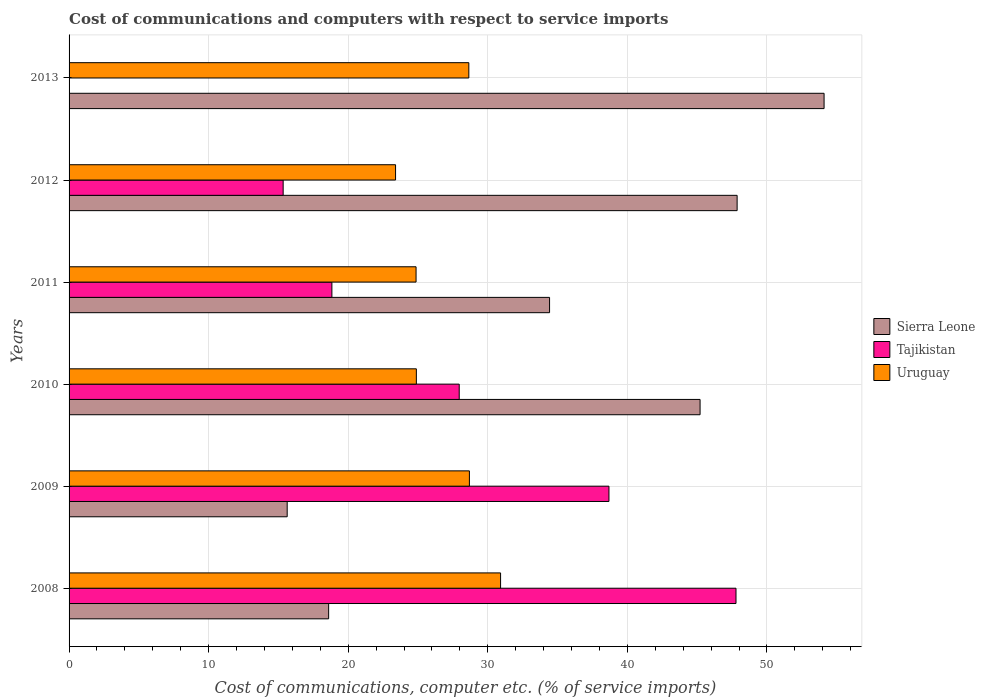Are the number of bars per tick equal to the number of legend labels?
Offer a very short reply. No. Are the number of bars on each tick of the Y-axis equal?
Offer a very short reply. No. How many bars are there on the 6th tick from the bottom?
Make the answer very short. 2. In how many cases, is the number of bars for a given year not equal to the number of legend labels?
Make the answer very short. 1. What is the cost of communications and computers in Uruguay in 2011?
Your answer should be very brief. 24.86. Across all years, what is the maximum cost of communications and computers in Sierra Leone?
Your response must be concise. 54.09. In which year was the cost of communications and computers in Uruguay maximum?
Keep it short and to the point. 2008. What is the total cost of communications and computers in Uruguay in the graph?
Your answer should be compact. 161.36. What is the difference between the cost of communications and computers in Sierra Leone in 2009 and that in 2013?
Offer a very short reply. -38.46. What is the difference between the cost of communications and computers in Sierra Leone in 2008 and the cost of communications and computers in Uruguay in 2012?
Make the answer very short. -4.79. What is the average cost of communications and computers in Tajikistan per year?
Give a very brief answer. 24.76. In the year 2008, what is the difference between the cost of communications and computers in Uruguay and cost of communications and computers in Sierra Leone?
Provide a short and direct response. 12.32. In how many years, is the cost of communications and computers in Sierra Leone greater than 24 %?
Offer a very short reply. 4. What is the ratio of the cost of communications and computers in Tajikistan in 2008 to that in 2011?
Provide a short and direct response. 2.54. Is the cost of communications and computers in Uruguay in 2011 less than that in 2012?
Give a very brief answer. No. What is the difference between the highest and the second highest cost of communications and computers in Sierra Leone?
Your response must be concise. 6.23. What is the difference between the highest and the lowest cost of communications and computers in Uruguay?
Offer a terse response. 7.52. In how many years, is the cost of communications and computers in Sierra Leone greater than the average cost of communications and computers in Sierra Leone taken over all years?
Offer a terse response. 3. Is the sum of the cost of communications and computers in Uruguay in 2010 and 2011 greater than the maximum cost of communications and computers in Tajikistan across all years?
Provide a short and direct response. Yes. Are all the bars in the graph horizontal?
Your response must be concise. Yes. Does the graph contain grids?
Keep it short and to the point. Yes. Where does the legend appear in the graph?
Offer a terse response. Center right. What is the title of the graph?
Offer a very short reply. Cost of communications and computers with respect to service imports. Does "Greece" appear as one of the legend labels in the graph?
Your answer should be very brief. No. What is the label or title of the X-axis?
Your answer should be compact. Cost of communications, computer etc. (% of service imports). What is the Cost of communications, computer etc. (% of service imports) in Sierra Leone in 2008?
Your response must be concise. 18.6. What is the Cost of communications, computer etc. (% of service imports) of Tajikistan in 2008?
Keep it short and to the point. 47.78. What is the Cost of communications, computer etc. (% of service imports) of Uruguay in 2008?
Make the answer very short. 30.91. What is the Cost of communications, computer etc. (% of service imports) in Sierra Leone in 2009?
Provide a short and direct response. 15.63. What is the Cost of communications, computer etc. (% of service imports) in Tajikistan in 2009?
Your answer should be compact. 38.68. What is the Cost of communications, computer etc. (% of service imports) of Uruguay in 2009?
Your response must be concise. 28.68. What is the Cost of communications, computer etc. (% of service imports) of Sierra Leone in 2010?
Give a very brief answer. 45.21. What is the Cost of communications, computer etc. (% of service imports) in Tajikistan in 2010?
Ensure brevity in your answer.  27.95. What is the Cost of communications, computer etc. (% of service imports) of Uruguay in 2010?
Make the answer very short. 24.88. What is the Cost of communications, computer etc. (% of service imports) of Sierra Leone in 2011?
Offer a terse response. 34.42. What is the Cost of communications, computer etc. (% of service imports) of Tajikistan in 2011?
Ensure brevity in your answer.  18.83. What is the Cost of communications, computer etc. (% of service imports) in Uruguay in 2011?
Provide a short and direct response. 24.86. What is the Cost of communications, computer etc. (% of service imports) in Sierra Leone in 2012?
Your answer should be compact. 47.86. What is the Cost of communications, computer etc. (% of service imports) in Tajikistan in 2012?
Your answer should be compact. 15.34. What is the Cost of communications, computer etc. (% of service imports) of Uruguay in 2012?
Give a very brief answer. 23.39. What is the Cost of communications, computer etc. (% of service imports) in Sierra Leone in 2013?
Make the answer very short. 54.09. What is the Cost of communications, computer etc. (% of service imports) in Uruguay in 2013?
Provide a succinct answer. 28.64. Across all years, what is the maximum Cost of communications, computer etc. (% of service imports) of Sierra Leone?
Keep it short and to the point. 54.09. Across all years, what is the maximum Cost of communications, computer etc. (% of service imports) of Tajikistan?
Provide a short and direct response. 47.78. Across all years, what is the maximum Cost of communications, computer etc. (% of service imports) of Uruguay?
Your response must be concise. 30.91. Across all years, what is the minimum Cost of communications, computer etc. (% of service imports) in Sierra Leone?
Your answer should be very brief. 15.63. Across all years, what is the minimum Cost of communications, computer etc. (% of service imports) in Uruguay?
Your answer should be compact. 23.39. What is the total Cost of communications, computer etc. (% of service imports) in Sierra Leone in the graph?
Offer a very short reply. 215.8. What is the total Cost of communications, computer etc. (% of service imports) in Tajikistan in the graph?
Ensure brevity in your answer.  148.58. What is the total Cost of communications, computer etc. (% of service imports) of Uruguay in the graph?
Give a very brief answer. 161.36. What is the difference between the Cost of communications, computer etc. (% of service imports) of Sierra Leone in 2008 and that in 2009?
Ensure brevity in your answer.  2.97. What is the difference between the Cost of communications, computer etc. (% of service imports) in Tajikistan in 2008 and that in 2009?
Give a very brief answer. 9.1. What is the difference between the Cost of communications, computer etc. (% of service imports) of Uruguay in 2008 and that in 2009?
Keep it short and to the point. 2.23. What is the difference between the Cost of communications, computer etc. (% of service imports) in Sierra Leone in 2008 and that in 2010?
Offer a terse response. -26.61. What is the difference between the Cost of communications, computer etc. (% of service imports) in Tajikistan in 2008 and that in 2010?
Your answer should be very brief. 19.83. What is the difference between the Cost of communications, computer etc. (% of service imports) of Uruguay in 2008 and that in 2010?
Your answer should be compact. 6.03. What is the difference between the Cost of communications, computer etc. (% of service imports) of Sierra Leone in 2008 and that in 2011?
Your response must be concise. -15.83. What is the difference between the Cost of communications, computer etc. (% of service imports) in Tajikistan in 2008 and that in 2011?
Your answer should be compact. 28.95. What is the difference between the Cost of communications, computer etc. (% of service imports) of Uruguay in 2008 and that in 2011?
Your answer should be compact. 6.06. What is the difference between the Cost of communications, computer etc. (% of service imports) in Sierra Leone in 2008 and that in 2012?
Give a very brief answer. -29.26. What is the difference between the Cost of communications, computer etc. (% of service imports) of Tajikistan in 2008 and that in 2012?
Make the answer very short. 32.44. What is the difference between the Cost of communications, computer etc. (% of service imports) of Uruguay in 2008 and that in 2012?
Provide a short and direct response. 7.52. What is the difference between the Cost of communications, computer etc. (% of service imports) in Sierra Leone in 2008 and that in 2013?
Ensure brevity in your answer.  -35.49. What is the difference between the Cost of communications, computer etc. (% of service imports) of Uruguay in 2008 and that in 2013?
Provide a short and direct response. 2.28. What is the difference between the Cost of communications, computer etc. (% of service imports) of Sierra Leone in 2009 and that in 2010?
Your answer should be compact. -29.58. What is the difference between the Cost of communications, computer etc. (% of service imports) of Tajikistan in 2009 and that in 2010?
Keep it short and to the point. 10.73. What is the difference between the Cost of communications, computer etc. (% of service imports) in Uruguay in 2009 and that in 2010?
Make the answer very short. 3.8. What is the difference between the Cost of communications, computer etc. (% of service imports) in Sierra Leone in 2009 and that in 2011?
Offer a very short reply. -18.8. What is the difference between the Cost of communications, computer etc. (% of service imports) of Tajikistan in 2009 and that in 2011?
Your answer should be very brief. 19.85. What is the difference between the Cost of communications, computer etc. (% of service imports) in Uruguay in 2009 and that in 2011?
Ensure brevity in your answer.  3.82. What is the difference between the Cost of communications, computer etc. (% of service imports) in Sierra Leone in 2009 and that in 2012?
Give a very brief answer. -32.23. What is the difference between the Cost of communications, computer etc. (% of service imports) of Tajikistan in 2009 and that in 2012?
Keep it short and to the point. 23.34. What is the difference between the Cost of communications, computer etc. (% of service imports) of Uruguay in 2009 and that in 2012?
Give a very brief answer. 5.29. What is the difference between the Cost of communications, computer etc. (% of service imports) of Sierra Leone in 2009 and that in 2013?
Offer a terse response. -38.46. What is the difference between the Cost of communications, computer etc. (% of service imports) in Uruguay in 2009 and that in 2013?
Your answer should be very brief. 0.04. What is the difference between the Cost of communications, computer etc. (% of service imports) of Sierra Leone in 2010 and that in 2011?
Make the answer very short. 10.78. What is the difference between the Cost of communications, computer etc. (% of service imports) of Tajikistan in 2010 and that in 2011?
Give a very brief answer. 9.12. What is the difference between the Cost of communications, computer etc. (% of service imports) in Uruguay in 2010 and that in 2011?
Offer a very short reply. 0.02. What is the difference between the Cost of communications, computer etc. (% of service imports) in Sierra Leone in 2010 and that in 2012?
Provide a short and direct response. -2.65. What is the difference between the Cost of communications, computer etc. (% of service imports) in Tajikistan in 2010 and that in 2012?
Ensure brevity in your answer.  12.61. What is the difference between the Cost of communications, computer etc. (% of service imports) in Uruguay in 2010 and that in 2012?
Give a very brief answer. 1.49. What is the difference between the Cost of communications, computer etc. (% of service imports) in Sierra Leone in 2010 and that in 2013?
Ensure brevity in your answer.  -8.88. What is the difference between the Cost of communications, computer etc. (% of service imports) of Uruguay in 2010 and that in 2013?
Offer a terse response. -3.76. What is the difference between the Cost of communications, computer etc. (% of service imports) of Sierra Leone in 2011 and that in 2012?
Provide a succinct answer. -13.44. What is the difference between the Cost of communications, computer etc. (% of service imports) of Tajikistan in 2011 and that in 2012?
Provide a succinct answer. 3.49. What is the difference between the Cost of communications, computer etc. (% of service imports) of Uruguay in 2011 and that in 2012?
Keep it short and to the point. 1.47. What is the difference between the Cost of communications, computer etc. (% of service imports) in Sierra Leone in 2011 and that in 2013?
Offer a very short reply. -19.67. What is the difference between the Cost of communications, computer etc. (% of service imports) in Uruguay in 2011 and that in 2013?
Offer a terse response. -3.78. What is the difference between the Cost of communications, computer etc. (% of service imports) of Sierra Leone in 2012 and that in 2013?
Give a very brief answer. -6.23. What is the difference between the Cost of communications, computer etc. (% of service imports) in Uruguay in 2012 and that in 2013?
Keep it short and to the point. -5.25. What is the difference between the Cost of communications, computer etc. (% of service imports) in Sierra Leone in 2008 and the Cost of communications, computer etc. (% of service imports) in Tajikistan in 2009?
Provide a short and direct response. -20.08. What is the difference between the Cost of communications, computer etc. (% of service imports) of Sierra Leone in 2008 and the Cost of communications, computer etc. (% of service imports) of Uruguay in 2009?
Give a very brief answer. -10.09. What is the difference between the Cost of communications, computer etc. (% of service imports) of Tajikistan in 2008 and the Cost of communications, computer etc. (% of service imports) of Uruguay in 2009?
Offer a very short reply. 19.1. What is the difference between the Cost of communications, computer etc. (% of service imports) in Sierra Leone in 2008 and the Cost of communications, computer etc. (% of service imports) in Tajikistan in 2010?
Keep it short and to the point. -9.36. What is the difference between the Cost of communications, computer etc. (% of service imports) of Sierra Leone in 2008 and the Cost of communications, computer etc. (% of service imports) of Uruguay in 2010?
Your answer should be compact. -6.28. What is the difference between the Cost of communications, computer etc. (% of service imports) of Tajikistan in 2008 and the Cost of communications, computer etc. (% of service imports) of Uruguay in 2010?
Offer a very short reply. 22.9. What is the difference between the Cost of communications, computer etc. (% of service imports) of Sierra Leone in 2008 and the Cost of communications, computer etc. (% of service imports) of Tajikistan in 2011?
Your response must be concise. -0.23. What is the difference between the Cost of communications, computer etc. (% of service imports) of Sierra Leone in 2008 and the Cost of communications, computer etc. (% of service imports) of Uruguay in 2011?
Offer a very short reply. -6.26. What is the difference between the Cost of communications, computer etc. (% of service imports) in Tajikistan in 2008 and the Cost of communications, computer etc. (% of service imports) in Uruguay in 2011?
Your response must be concise. 22.92. What is the difference between the Cost of communications, computer etc. (% of service imports) of Sierra Leone in 2008 and the Cost of communications, computer etc. (% of service imports) of Tajikistan in 2012?
Provide a succinct answer. 3.26. What is the difference between the Cost of communications, computer etc. (% of service imports) of Sierra Leone in 2008 and the Cost of communications, computer etc. (% of service imports) of Uruguay in 2012?
Offer a terse response. -4.79. What is the difference between the Cost of communications, computer etc. (% of service imports) in Tajikistan in 2008 and the Cost of communications, computer etc. (% of service imports) in Uruguay in 2012?
Your answer should be very brief. 24.39. What is the difference between the Cost of communications, computer etc. (% of service imports) of Sierra Leone in 2008 and the Cost of communications, computer etc. (% of service imports) of Uruguay in 2013?
Offer a terse response. -10.04. What is the difference between the Cost of communications, computer etc. (% of service imports) in Tajikistan in 2008 and the Cost of communications, computer etc. (% of service imports) in Uruguay in 2013?
Your response must be concise. 19.14. What is the difference between the Cost of communications, computer etc. (% of service imports) in Sierra Leone in 2009 and the Cost of communications, computer etc. (% of service imports) in Tajikistan in 2010?
Keep it short and to the point. -12.33. What is the difference between the Cost of communications, computer etc. (% of service imports) in Sierra Leone in 2009 and the Cost of communications, computer etc. (% of service imports) in Uruguay in 2010?
Provide a succinct answer. -9.25. What is the difference between the Cost of communications, computer etc. (% of service imports) of Tajikistan in 2009 and the Cost of communications, computer etc. (% of service imports) of Uruguay in 2010?
Keep it short and to the point. 13.8. What is the difference between the Cost of communications, computer etc. (% of service imports) in Sierra Leone in 2009 and the Cost of communications, computer etc. (% of service imports) in Tajikistan in 2011?
Offer a terse response. -3.2. What is the difference between the Cost of communications, computer etc. (% of service imports) in Sierra Leone in 2009 and the Cost of communications, computer etc. (% of service imports) in Uruguay in 2011?
Offer a terse response. -9.23. What is the difference between the Cost of communications, computer etc. (% of service imports) of Tajikistan in 2009 and the Cost of communications, computer etc. (% of service imports) of Uruguay in 2011?
Offer a terse response. 13.82. What is the difference between the Cost of communications, computer etc. (% of service imports) in Sierra Leone in 2009 and the Cost of communications, computer etc. (% of service imports) in Tajikistan in 2012?
Give a very brief answer. 0.29. What is the difference between the Cost of communications, computer etc. (% of service imports) in Sierra Leone in 2009 and the Cost of communications, computer etc. (% of service imports) in Uruguay in 2012?
Provide a short and direct response. -7.76. What is the difference between the Cost of communications, computer etc. (% of service imports) in Tajikistan in 2009 and the Cost of communications, computer etc. (% of service imports) in Uruguay in 2012?
Make the answer very short. 15.29. What is the difference between the Cost of communications, computer etc. (% of service imports) in Sierra Leone in 2009 and the Cost of communications, computer etc. (% of service imports) in Uruguay in 2013?
Your answer should be very brief. -13.01. What is the difference between the Cost of communications, computer etc. (% of service imports) in Tajikistan in 2009 and the Cost of communications, computer etc. (% of service imports) in Uruguay in 2013?
Make the answer very short. 10.04. What is the difference between the Cost of communications, computer etc. (% of service imports) in Sierra Leone in 2010 and the Cost of communications, computer etc. (% of service imports) in Tajikistan in 2011?
Make the answer very short. 26.38. What is the difference between the Cost of communications, computer etc. (% of service imports) in Sierra Leone in 2010 and the Cost of communications, computer etc. (% of service imports) in Uruguay in 2011?
Ensure brevity in your answer.  20.35. What is the difference between the Cost of communications, computer etc. (% of service imports) of Tajikistan in 2010 and the Cost of communications, computer etc. (% of service imports) of Uruguay in 2011?
Your answer should be very brief. 3.09. What is the difference between the Cost of communications, computer etc. (% of service imports) in Sierra Leone in 2010 and the Cost of communications, computer etc. (% of service imports) in Tajikistan in 2012?
Your response must be concise. 29.87. What is the difference between the Cost of communications, computer etc. (% of service imports) in Sierra Leone in 2010 and the Cost of communications, computer etc. (% of service imports) in Uruguay in 2012?
Provide a short and direct response. 21.82. What is the difference between the Cost of communications, computer etc. (% of service imports) in Tajikistan in 2010 and the Cost of communications, computer etc. (% of service imports) in Uruguay in 2012?
Give a very brief answer. 4.56. What is the difference between the Cost of communications, computer etc. (% of service imports) in Sierra Leone in 2010 and the Cost of communications, computer etc. (% of service imports) in Uruguay in 2013?
Give a very brief answer. 16.57. What is the difference between the Cost of communications, computer etc. (% of service imports) in Tajikistan in 2010 and the Cost of communications, computer etc. (% of service imports) in Uruguay in 2013?
Your answer should be very brief. -0.69. What is the difference between the Cost of communications, computer etc. (% of service imports) of Sierra Leone in 2011 and the Cost of communications, computer etc. (% of service imports) of Tajikistan in 2012?
Ensure brevity in your answer.  19.09. What is the difference between the Cost of communications, computer etc. (% of service imports) of Sierra Leone in 2011 and the Cost of communications, computer etc. (% of service imports) of Uruguay in 2012?
Your answer should be compact. 11.03. What is the difference between the Cost of communications, computer etc. (% of service imports) of Tajikistan in 2011 and the Cost of communications, computer etc. (% of service imports) of Uruguay in 2012?
Provide a succinct answer. -4.56. What is the difference between the Cost of communications, computer etc. (% of service imports) of Sierra Leone in 2011 and the Cost of communications, computer etc. (% of service imports) of Uruguay in 2013?
Provide a short and direct response. 5.78. What is the difference between the Cost of communications, computer etc. (% of service imports) of Tajikistan in 2011 and the Cost of communications, computer etc. (% of service imports) of Uruguay in 2013?
Ensure brevity in your answer.  -9.81. What is the difference between the Cost of communications, computer etc. (% of service imports) of Sierra Leone in 2012 and the Cost of communications, computer etc. (% of service imports) of Uruguay in 2013?
Ensure brevity in your answer.  19.22. What is the difference between the Cost of communications, computer etc. (% of service imports) of Tajikistan in 2012 and the Cost of communications, computer etc. (% of service imports) of Uruguay in 2013?
Your answer should be very brief. -13.3. What is the average Cost of communications, computer etc. (% of service imports) of Sierra Leone per year?
Provide a succinct answer. 35.97. What is the average Cost of communications, computer etc. (% of service imports) in Tajikistan per year?
Keep it short and to the point. 24.76. What is the average Cost of communications, computer etc. (% of service imports) of Uruguay per year?
Provide a short and direct response. 26.89. In the year 2008, what is the difference between the Cost of communications, computer etc. (% of service imports) of Sierra Leone and Cost of communications, computer etc. (% of service imports) of Tajikistan?
Your answer should be compact. -29.18. In the year 2008, what is the difference between the Cost of communications, computer etc. (% of service imports) in Sierra Leone and Cost of communications, computer etc. (% of service imports) in Uruguay?
Offer a terse response. -12.32. In the year 2008, what is the difference between the Cost of communications, computer etc. (% of service imports) of Tajikistan and Cost of communications, computer etc. (% of service imports) of Uruguay?
Your answer should be compact. 16.87. In the year 2009, what is the difference between the Cost of communications, computer etc. (% of service imports) of Sierra Leone and Cost of communications, computer etc. (% of service imports) of Tajikistan?
Your answer should be very brief. -23.05. In the year 2009, what is the difference between the Cost of communications, computer etc. (% of service imports) in Sierra Leone and Cost of communications, computer etc. (% of service imports) in Uruguay?
Keep it short and to the point. -13.06. In the year 2009, what is the difference between the Cost of communications, computer etc. (% of service imports) of Tajikistan and Cost of communications, computer etc. (% of service imports) of Uruguay?
Offer a very short reply. 10. In the year 2010, what is the difference between the Cost of communications, computer etc. (% of service imports) of Sierra Leone and Cost of communications, computer etc. (% of service imports) of Tajikistan?
Provide a succinct answer. 17.26. In the year 2010, what is the difference between the Cost of communications, computer etc. (% of service imports) in Sierra Leone and Cost of communications, computer etc. (% of service imports) in Uruguay?
Offer a very short reply. 20.33. In the year 2010, what is the difference between the Cost of communications, computer etc. (% of service imports) in Tajikistan and Cost of communications, computer etc. (% of service imports) in Uruguay?
Provide a short and direct response. 3.07. In the year 2011, what is the difference between the Cost of communications, computer etc. (% of service imports) in Sierra Leone and Cost of communications, computer etc. (% of service imports) in Tajikistan?
Provide a short and direct response. 15.59. In the year 2011, what is the difference between the Cost of communications, computer etc. (% of service imports) of Sierra Leone and Cost of communications, computer etc. (% of service imports) of Uruguay?
Provide a short and direct response. 9.56. In the year 2011, what is the difference between the Cost of communications, computer etc. (% of service imports) in Tajikistan and Cost of communications, computer etc. (% of service imports) in Uruguay?
Give a very brief answer. -6.03. In the year 2012, what is the difference between the Cost of communications, computer etc. (% of service imports) of Sierra Leone and Cost of communications, computer etc. (% of service imports) of Tajikistan?
Keep it short and to the point. 32.52. In the year 2012, what is the difference between the Cost of communications, computer etc. (% of service imports) of Sierra Leone and Cost of communications, computer etc. (% of service imports) of Uruguay?
Offer a terse response. 24.47. In the year 2012, what is the difference between the Cost of communications, computer etc. (% of service imports) of Tajikistan and Cost of communications, computer etc. (% of service imports) of Uruguay?
Make the answer very short. -8.05. In the year 2013, what is the difference between the Cost of communications, computer etc. (% of service imports) of Sierra Leone and Cost of communications, computer etc. (% of service imports) of Uruguay?
Keep it short and to the point. 25.45. What is the ratio of the Cost of communications, computer etc. (% of service imports) of Sierra Leone in 2008 to that in 2009?
Make the answer very short. 1.19. What is the ratio of the Cost of communications, computer etc. (% of service imports) in Tajikistan in 2008 to that in 2009?
Make the answer very short. 1.24. What is the ratio of the Cost of communications, computer etc. (% of service imports) of Uruguay in 2008 to that in 2009?
Ensure brevity in your answer.  1.08. What is the ratio of the Cost of communications, computer etc. (% of service imports) in Sierra Leone in 2008 to that in 2010?
Offer a very short reply. 0.41. What is the ratio of the Cost of communications, computer etc. (% of service imports) in Tajikistan in 2008 to that in 2010?
Offer a terse response. 1.71. What is the ratio of the Cost of communications, computer etc. (% of service imports) of Uruguay in 2008 to that in 2010?
Your response must be concise. 1.24. What is the ratio of the Cost of communications, computer etc. (% of service imports) in Sierra Leone in 2008 to that in 2011?
Your response must be concise. 0.54. What is the ratio of the Cost of communications, computer etc. (% of service imports) of Tajikistan in 2008 to that in 2011?
Offer a terse response. 2.54. What is the ratio of the Cost of communications, computer etc. (% of service imports) in Uruguay in 2008 to that in 2011?
Your answer should be very brief. 1.24. What is the ratio of the Cost of communications, computer etc. (% of service imports) in Sierra Leone in 2008 to that in 2012?
Offer a terse response. 0.39. What is the ratio of the Cost of communications, computer etc. (% of service imports) in Tajikistan in 2008 to that in 2012?
Keep it short and to the point. 3.12. What is the ratio of the Cost of communications, computer etc. (% of service imports) in Uruguay in 2008 to that in 2012?
Give a very brief answer. 1.32. What is the ratio of the Cost of communications, computer etc. (% of service imports) of Sierra Leone in 2008 to that in 2013?
Provide a short and direct response. 0.34. What is the ratio of the Cost of communications, computer etc. (% of service imports) of Uruguay in 2008 to that in 2013?
Offer a very short reply. 1.08. What is the ratio of the Cost of communications, computer etc. (% of service imports) of Sierra Leone in 2009 to that in 2010?
Give a very brief answer. 0.35. What is the ratio of the Cost of communications, computer etc. (% of service imports) in Tajikistan in 2009 to that in 2010?
Keep it short and to the point. 1.38. What is the ratio of the Cost of communications, computer etc. (% of service imports) of Uruguay in 2009 to that in 2010?
Your answer should be compact. 1.15. What is the ratio of the Cost of communications, computer etc. (% of service imports) of Sierra Leone in 2009 to that in 2011?
Provide a short and direct response. 0.45. What is the ratio of the Cost of communications, computer etc. (% of service imports) of Tajikistan in 2009 to that in 2011?
Give a very brief answer. 2.05. What is the ratio of the Cost of communications, computer etc. (% of service imports) of Uruguay in 2009 to that in 2011?
Provide a succinct answer. 1.15. What is the ratio of the Cost of communications, computer etc. (% of service imports) in Sierra Leone in 2009 to that in 2012?
Give a very brief answer. 0.33. What is the ratio of the Cost of communications, computer etc. (% of service imports) of Tajikistan in 2009 to that in 2012?
Your response must be concise. 2.52. What is the ratio of the Cost of communications, computer etc. (% of service imports) in Uruguay in 2009 to that in 2012?
Make the answer very short. 1.23. What is the ratio of the Cost of communications, computer etc. (% of service imports) in Sierra Leone in 2009 to that in 2013?
Provide a short and direct response. 0.29. What is the ratio of the Cost of communications, computer etc. (% of service imports) of Uruguay in 2009 to that in 2013?
Make the answer very short. 1. What is the ratio of the Cost of communications, computer etc. (% of service imports) of Sierra Leone in 2010 to that in 2011?
Your answer should be very brief. 1.31. What is the ratio of the Cost of communications, computer etc. (% of service imports) of Tajikistan in 2010 to that in 2011?
Your response must be concise. 1.48. What is the ratio of the Cost of communications, computer etc. (% of service imports) in Sierra Leone in 2010 to that in 2012?
Offer a very short reply. 0.94. What is the ratio of the Cost of communications, computer etc. (% of service imports) of Tajikistan in 2010 to that in 2012?
Your response must be concise. 1.82. What is the ratio of the Cost of communications, computer etc. (% of service imports) in Uruguay in 2010 to that in 2012?
Your response must be concise. 1.06. What is the ratio of the Cost of communications, computer etc. (% of service imports) of Sierra Leone in 2010 to that in 2013?
Provide a short and direct response. 0.84. What is the ratio of the Cost of communications, computer etc. (% of service imports) of Uruguay in 2010 to that in 2013?
Your response must be concise. 0.87. What is the ratio of the Cost of communications, computer etc. (% of service imports) in Sierra Leone in 2011 to that in 2012?
Provide a short and direct response. 0.72. What is the ratio of the Cost of communications, computer etc. (% of service imports) of Tajikistan in 2011 to that in 2012?
Give a very brief answer. 1.23. What is the ratio of the Cost of communications, computer etc. (% of service imports) in Uruguay in 2011 to that in 2012?
Your answer should be compact. 1.06. What is the ratio of the Cost of communications, computer etc. (% of service imports) of Sierra Leone in 2011 to that in 2013?
Provide a short and direct response. 0.64. What is the ratio of the Cost of communications, computer etc. (% of service imports) in Uruguay in 2011 to that in 2013?
Ensure brevity in your answer.  0.87. What is the ratio of the Cost of communications, computer etc. (% of service imports) in Sierra Leone in 2012 to that in 2013?
Offer a terse response. 0.88. What is the ratio of the Cost of communications, computer etc. (% of service imports) of Uruguay in 2012 to that in 2013?
Offer a terse response. 0.82. What is the difference between the highest and the second highest Cost of communications, computer etc. (% of service imports) of Sierra Leone?
Your answer should be very brief. 6.23. What is the difference between the highest and the second highest Cost of communications, computer etc. (% of service imports) of Tajikistan?
Provide a succinct answer. 9.1. What is the difference between the highest and the second highest Cost of communications, computer etc. (% of service imports) of Uruguay?
Your answer should be very brief. 2.23. What is the difference between the highest and the lowest Cost of communications, computer etc. (% of service imports) of Sierra Leone?
Make the answer very short. 38.46. What is the difference between the highest and the lowest Cost of communications, computer etc. (% of service imports) in Tajikistan?
Your answer should be very brief. 47.78. What is the difference between the highest and the lowest Cost of communications, computer etc. (% of service imports) of Uruguay?
Give a very brief answer. 7.52. 